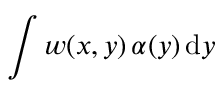Convert formula to latex. <formula><loc_0><loc_0><loc_500><loc_500>\int w ( x , y ) \, \alpha ( y ) \, d y</formula> 